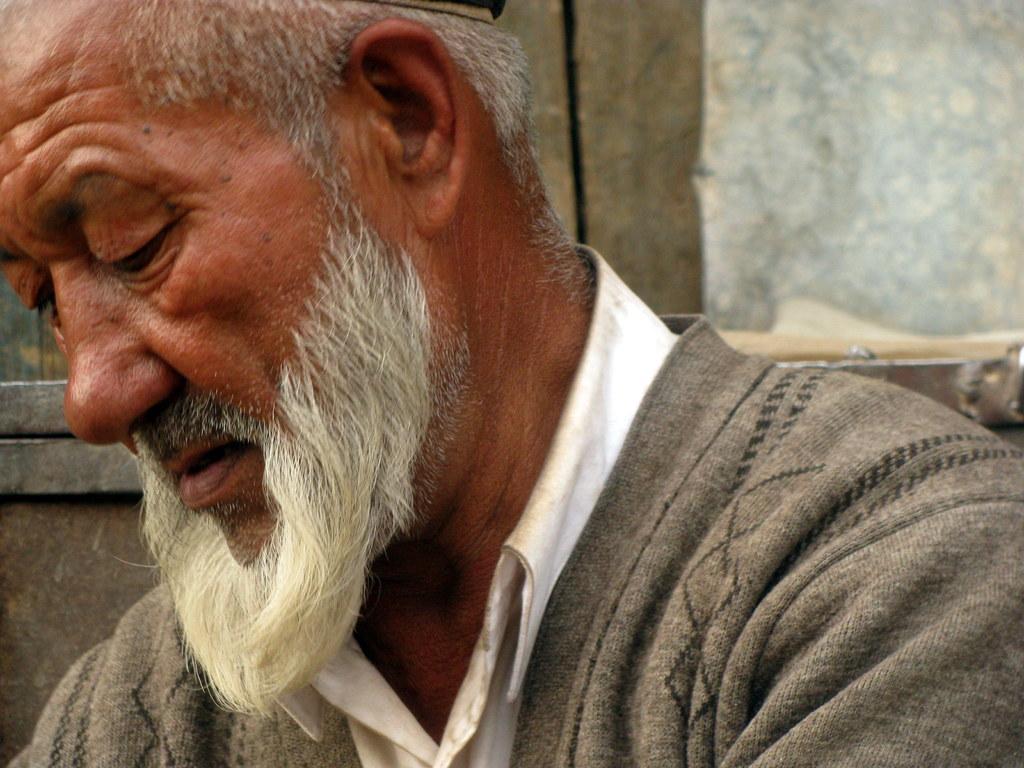Describe this image in one or two sentences. There is a person in gray color jacket sitting. In the background there is wall. 